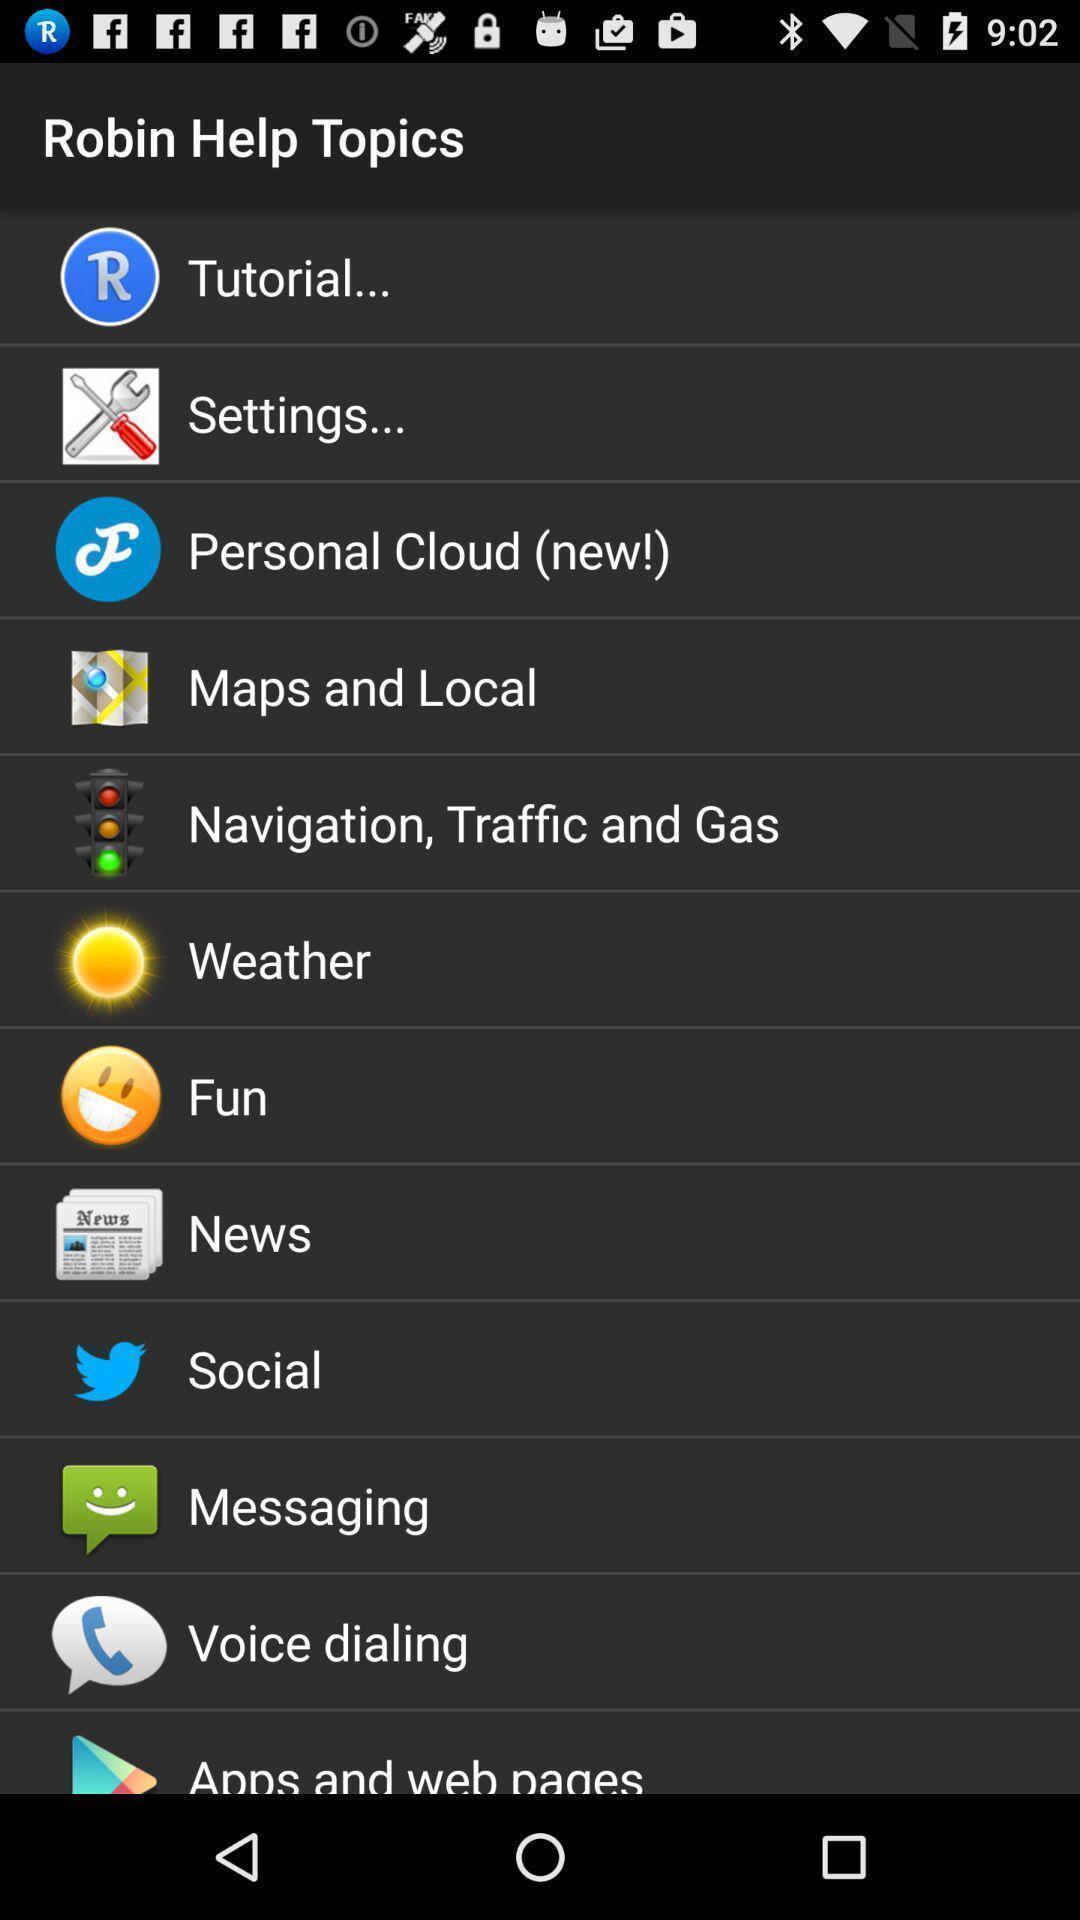Please provide a description for this image. Various options displayed. 